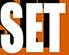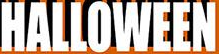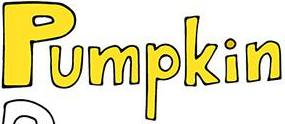What text is displayed in these images sequentially, separated by a semicolon? SET; HALLOWEEN; Pumpkin 